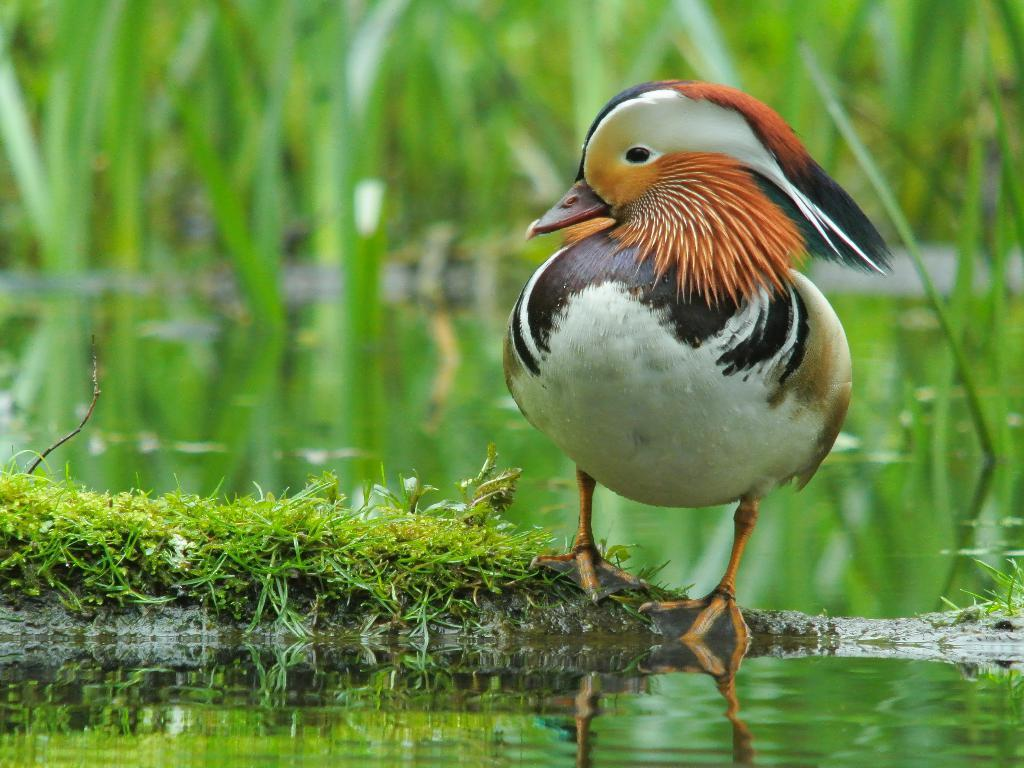What type of animal can be seen on the right side of the image? There is a bird on the right side of the image. Where is the bird located? The bird is on a wall. What type of environment is depicted in the image? There is greenery in the image, suggesting a natural setting. What can be seen at the bottom side of the image? There is water at the bottom side of the image. How much money is the bird holding in the image? There is no money present in the image; it features a bird on a wall. What type of toothbrush is the bird using in the image? There is no toothbrush present in the image; it features a bird on a wall. 